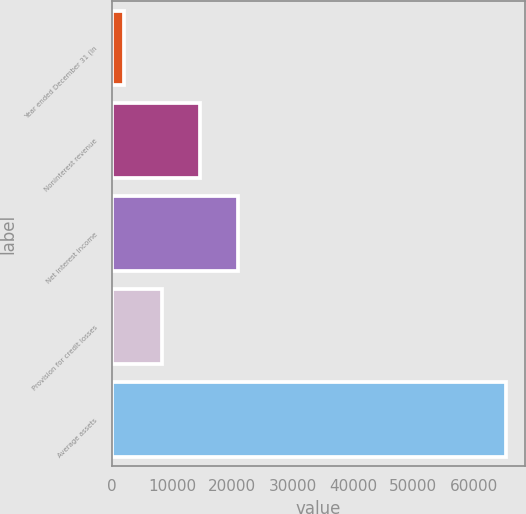Convert chart. <chart><loc_0><loc_0><loc_500><loc_500><bar_chart><fcel>Year ended December 31 (in<fcel>Noninterest revenue<fcel>Net interest income<fcel>Provision for credit losses<fcel>Average assets<nl><fcel>2006<fcel>14658<fcel>20984<fcel>8332<fcel>65266<nl></chart> 